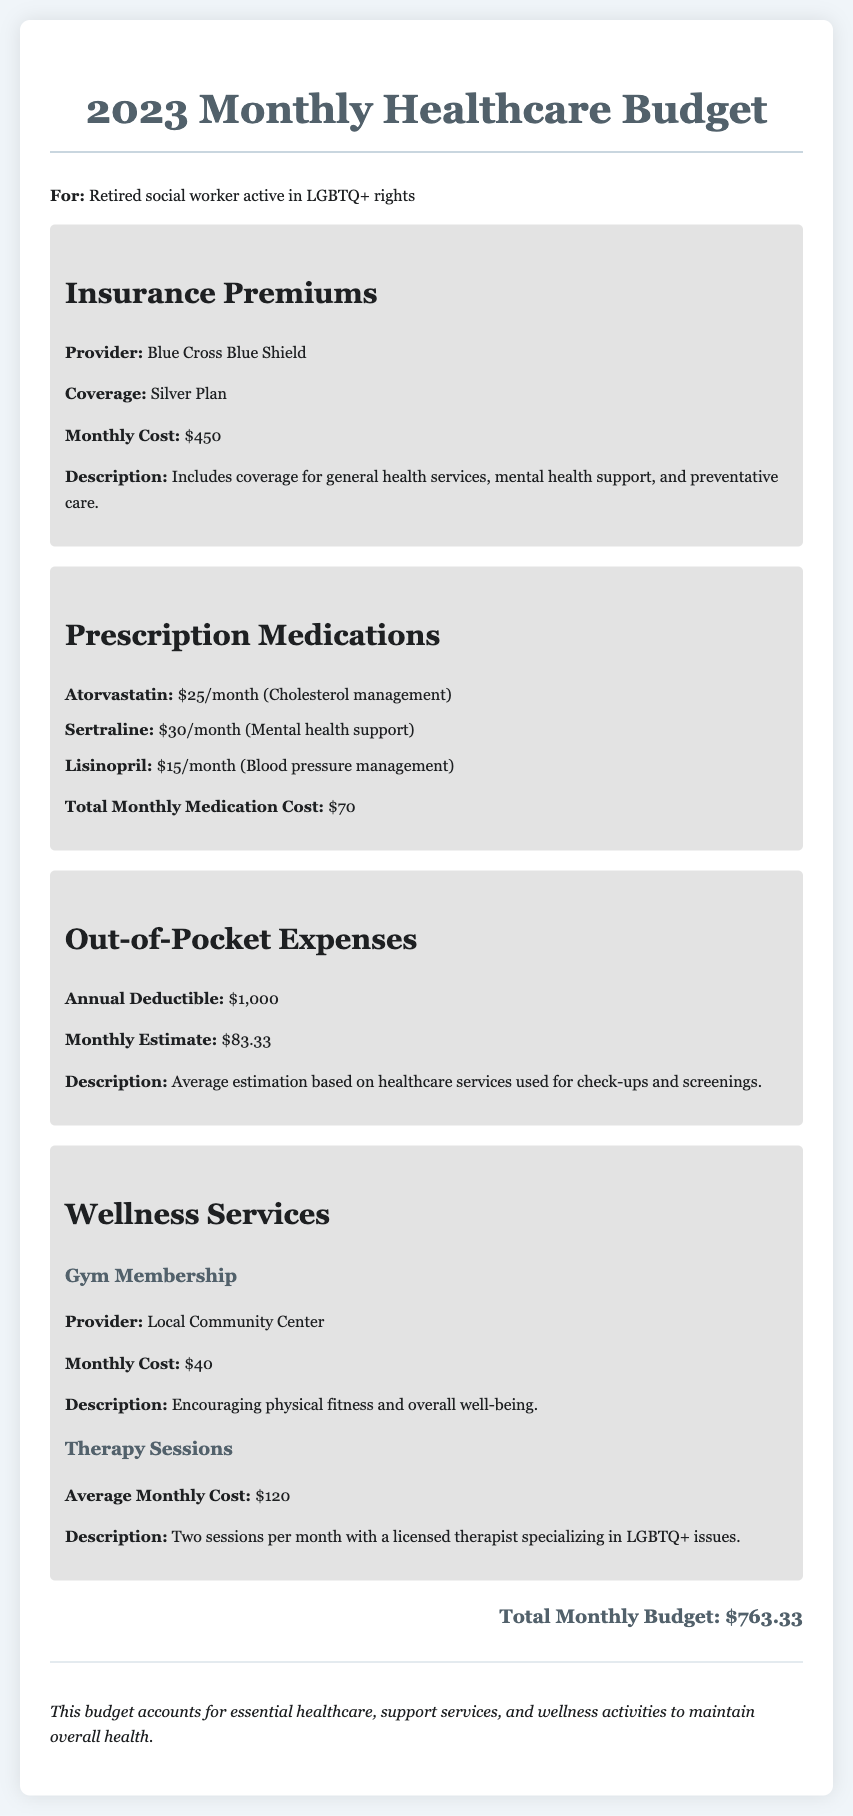What is the monthly cost of insurance premiums? The monthly cost of insurance premiums is stated in the budget as $450.
Answer: $450 How much does Atorvastatin cost per month? The cost of Atorvastatin, listed under prescription medications, is $25 per month.
Answer: $25 What is the total monthly cost of prescription medications? The document states the total monthly medication cost to be $70 when adding individual medication costs.
Answer: $70 What is the annual deductible mentioned? The annual deductible is mentioned as $1,000 in the out-of-pocket expenses section.
Answer: $1,000 What is the average monthly cost of therapy sessions? The average monthly cost for therapy sessions is stated to be $120.
Answer: $120 What is the total monthly budget outlined in the document? The total monthly budget is calculated as $763.33, which includes all expenses.
Answer: $763.33 What wellness service has a monthly cost of $40? The gym membership from the local community center has a monthly cost of $40.
Answer: $40 Which insurance provider is listed in the document? The insurance provider mentioned is Blue Cross Blue Shield.
Answer: Blue Cross Blue Shield What type of plan is the insurance premium for? The insurance premium is for a Silver Plan as specified in the document.
Answer: Silver Plan What is the total monthly estimate for out-of-pocket expenses? The total monthly estimate for out-of-pocket expenses is provided as $83.33.
Answer: $83.33 